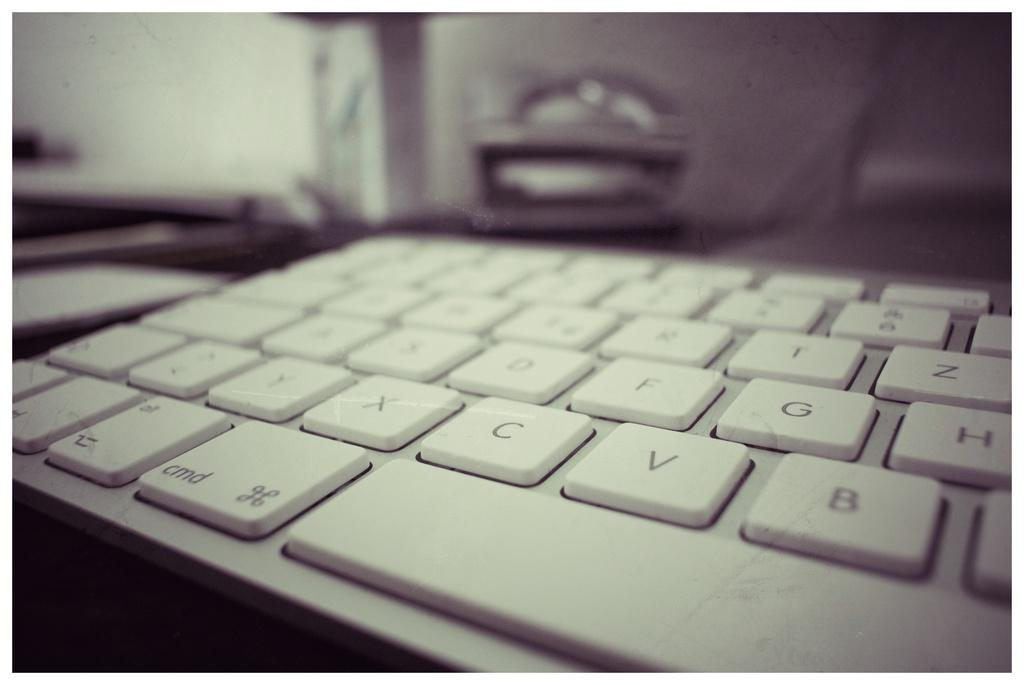What is the main object in the image? There is a keyboard in the image. What feature does the keyboard have? The keyboard has keys. Can you describe the background of the image? The background of the image is blurred. What type of secretary is sitting behind the keyboard in the image? There is no secretary present in the image; it only shows a keyboard with keys. What task is the maid performing with the keyboard in the image? There is no maid present in the image, and the keyboard is not being used for any task. 